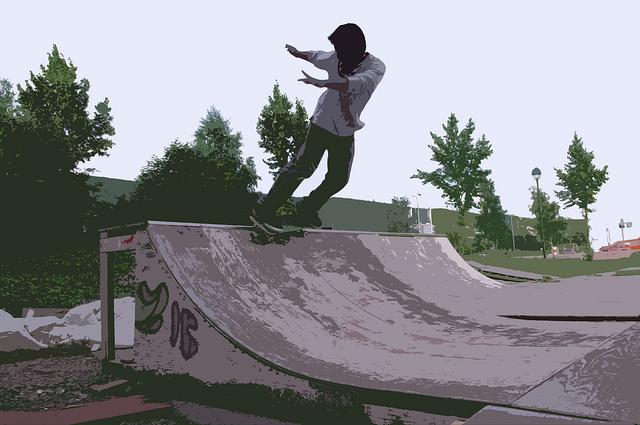What is the man doing?
Write a very short answer. Skateboarding. Has this photo been digitally altered?
Give a very brief answer. Yes. Is the man dancing?
Short answer required. No. What material makes up the structure he's skating on?
Write a very short answer. Wood. 